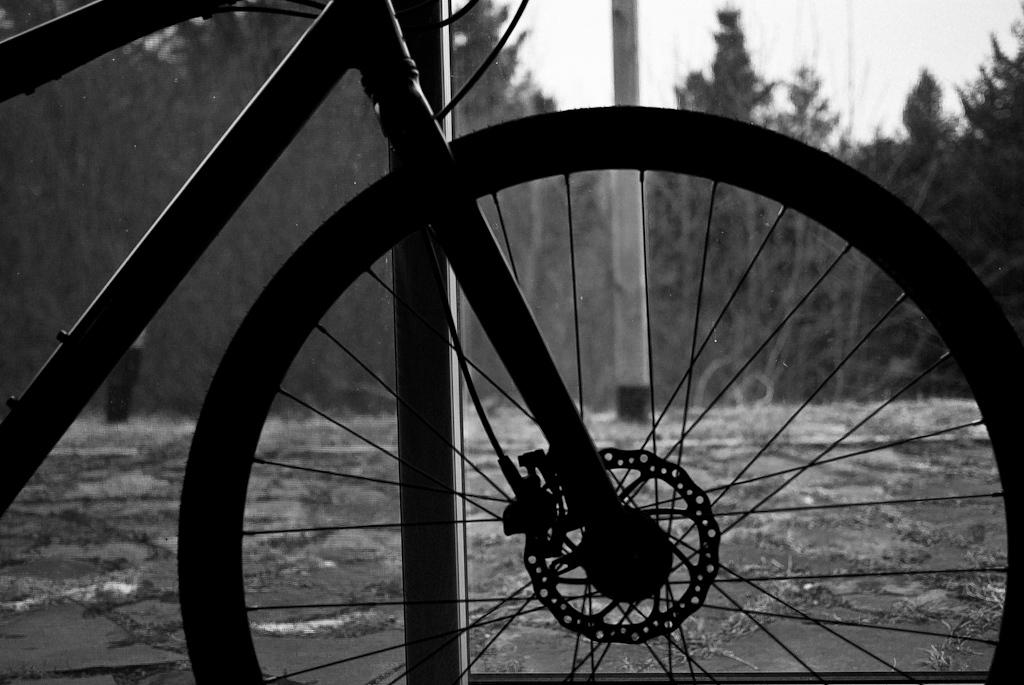What is the main mode of transportation visible in the image? There is a cycle in the image. What type of natural scenery can be seen in the background of the image? There are trees visible at the backside of the image. Is there a servant attending to the cycle in the image? There is no servant present in the image. What type of shoe is the person riding the cycle wearing? There is no person riding the cycle visible in the image, so it is not possible to determine what type of shoe they might be wearing. 